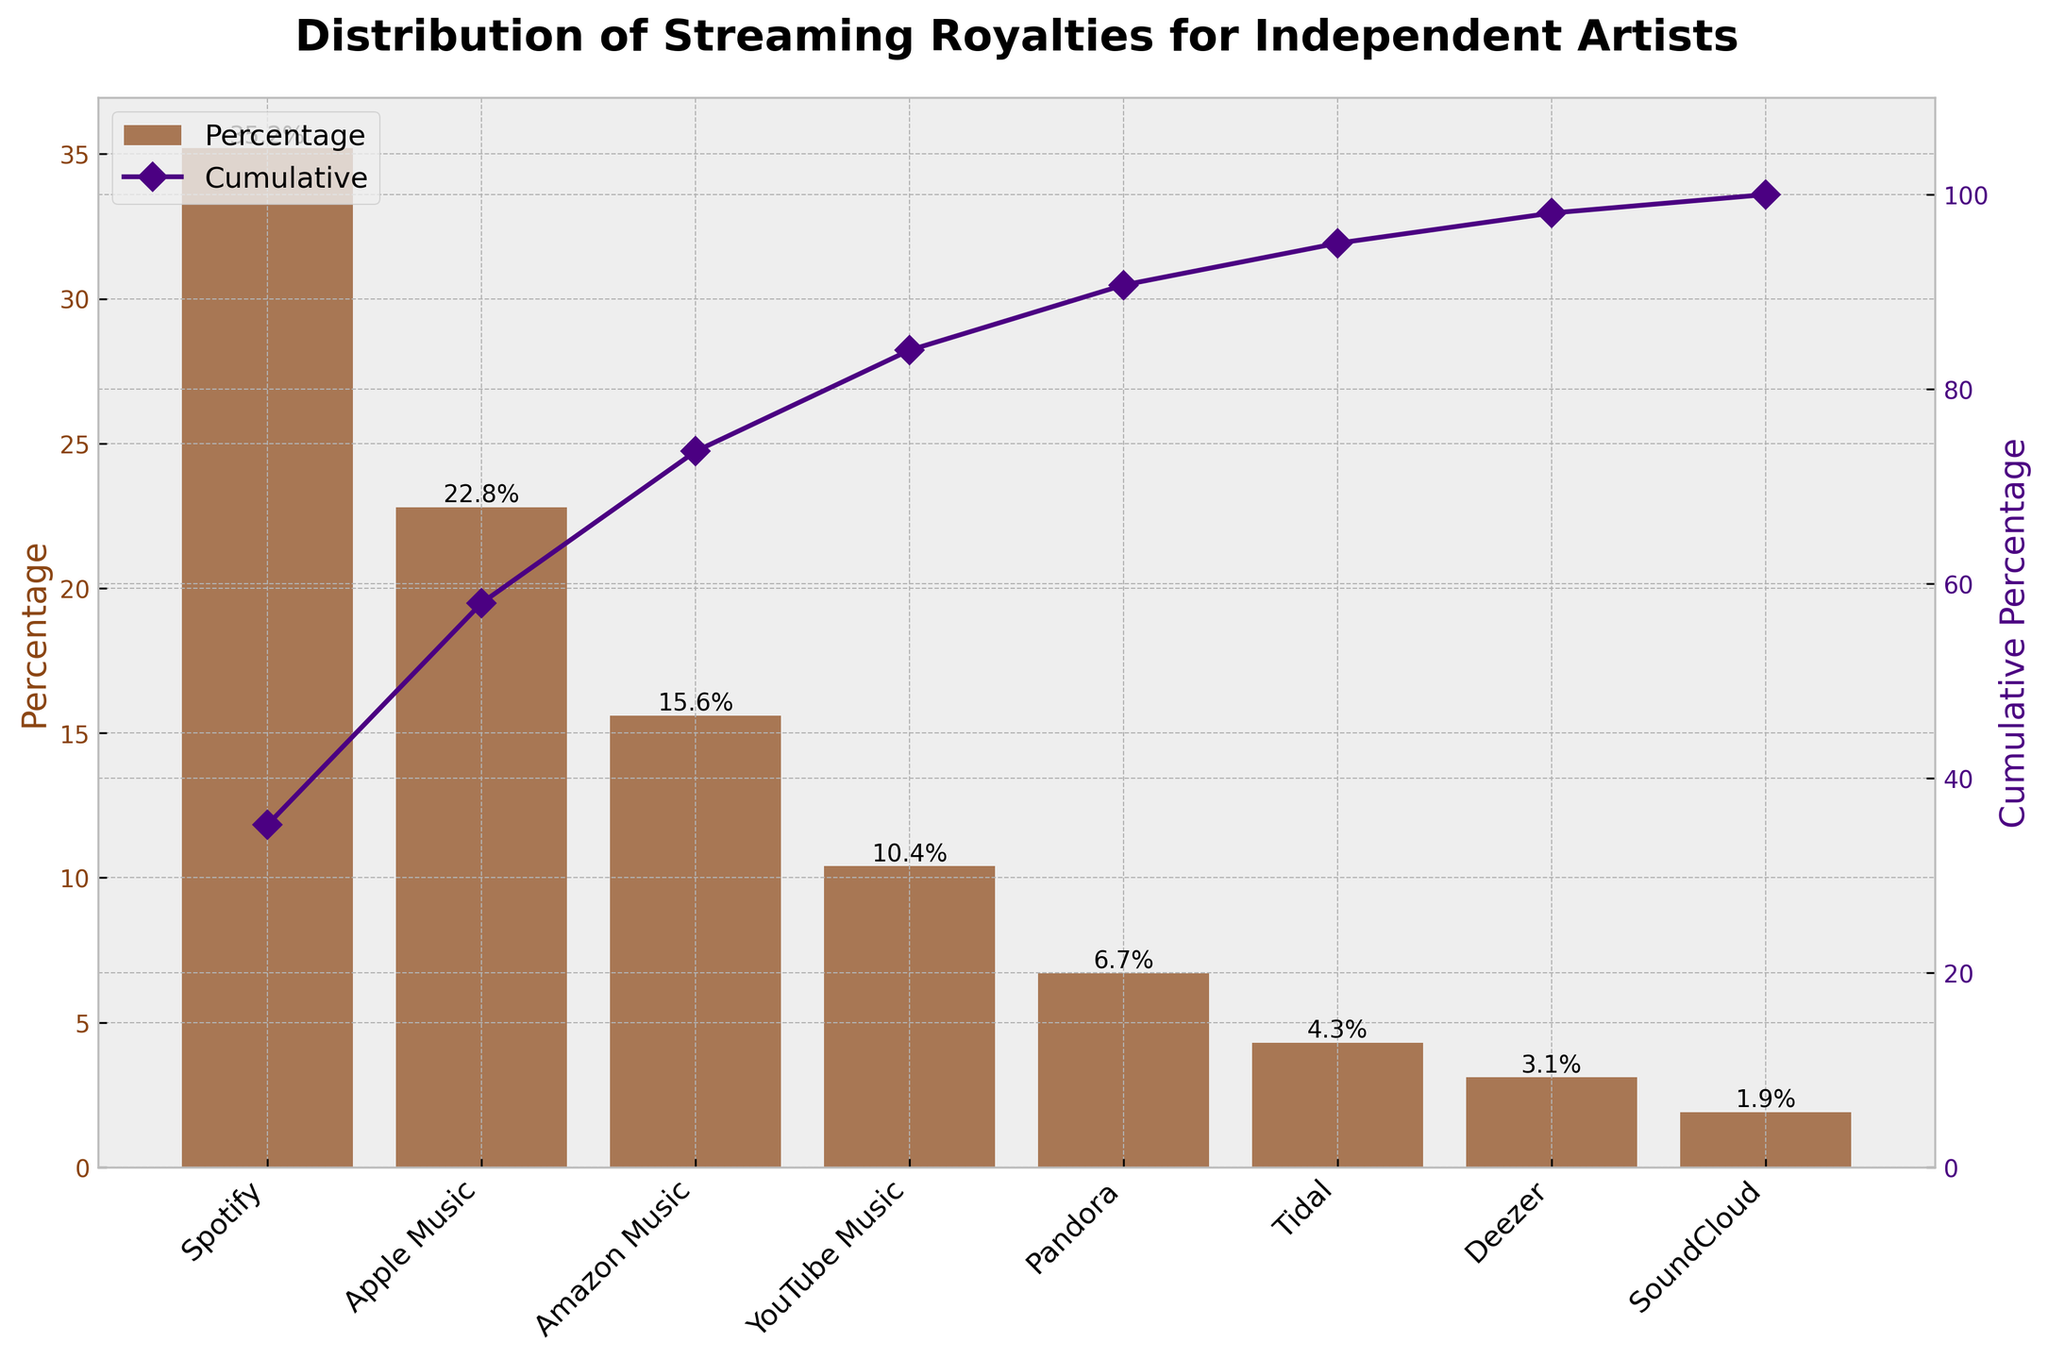What's the title of the chart? The title of the chart is prominently displayed at the top of the figure and indicates the main topic of the chart.
Answer: Distribution of Streaming Royalties for Independent Artists How many platforms are represented in the chart? Count the number of distinct bar columns in the chart, as each represents a different platform.
Answer: 8 Which platform has the highest percentage of streaming royalties? Look for the tallest bar in the bar chart; the label at its base will identify the platform.
Answer: Spotify What is the percentage of streaming royalties for Tidal? Locate the bar labeled "Tidal" and read the percentage indicated at the top of the bar.
Answer: 4.3% What's the cumulative percentage up to Amazon Music? Identify Amazon Music in the x-axis, then follow the cumulative line to the y-axis on the right to determine the cumulative percentage.
Answer: 73.6% How does Apple Music's percentage compare to Amazon Music's percentage? Look at both bars—find the heights and compare them, referring to the percentage values labeled at the top of each bar.
Answer: Apple Music is higher than Amazon Music by 7.2% Which platform's bar comes immediately before SoundCloud in terms of decreasing order of percentages? The bars are sorted from highest to lowest; locate SoundCloud's bar and note the label on the bar immediately to its left.
Answer: Deezer What's the combined percentage of Spotify, Apple Music, and Amazon Music? Sum the percentages of the three platforms: 35.2% (Spotify) + 22.8% (Apple Music) + 15.6% (Amazon Music).
Answer: 73.6% What is the cumulative percentage of streaming royalties for YouTube Music, Pandora, and Deezer together? Determine the cumulative percentages at YouTube Music, Pandora, and Deezer, then find the difference between YouTube Music and Deezer. Cumulative at YouTube Music is 84%, Pandora is 90.7%, and Deezer is 97.5%. Subtract cumulative at YouTube Music from Deezer.
Answer: 13.5% Which platform has the smallest contribution to the streaming royalties? Find the shortest bar in the bar chart and identify the platform at its base labeling.
Answer: SoundCloud 